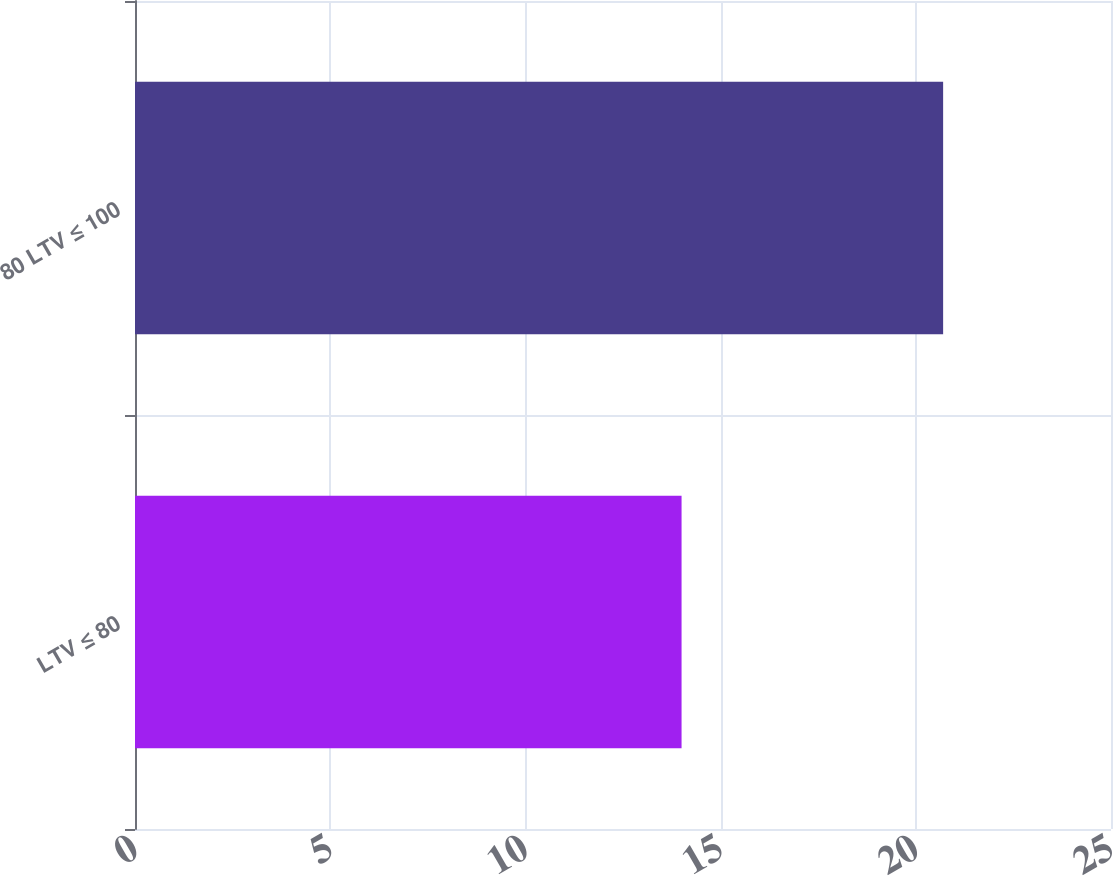Convert chart to OTSL. <chart><loc_0><loc_0><loc_500><loc_500><bar_chart><fcel>LTV ≤ 80<fcel>80 LTV ≤ 100<nl><fcel>14<fcel>20.7<nl></chart> 